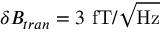<formula> <loc_0><loc_0><loc_500><loc_500>\delta B _ { t r a n } = 3 f T / \sqrt { H z }</formula> 